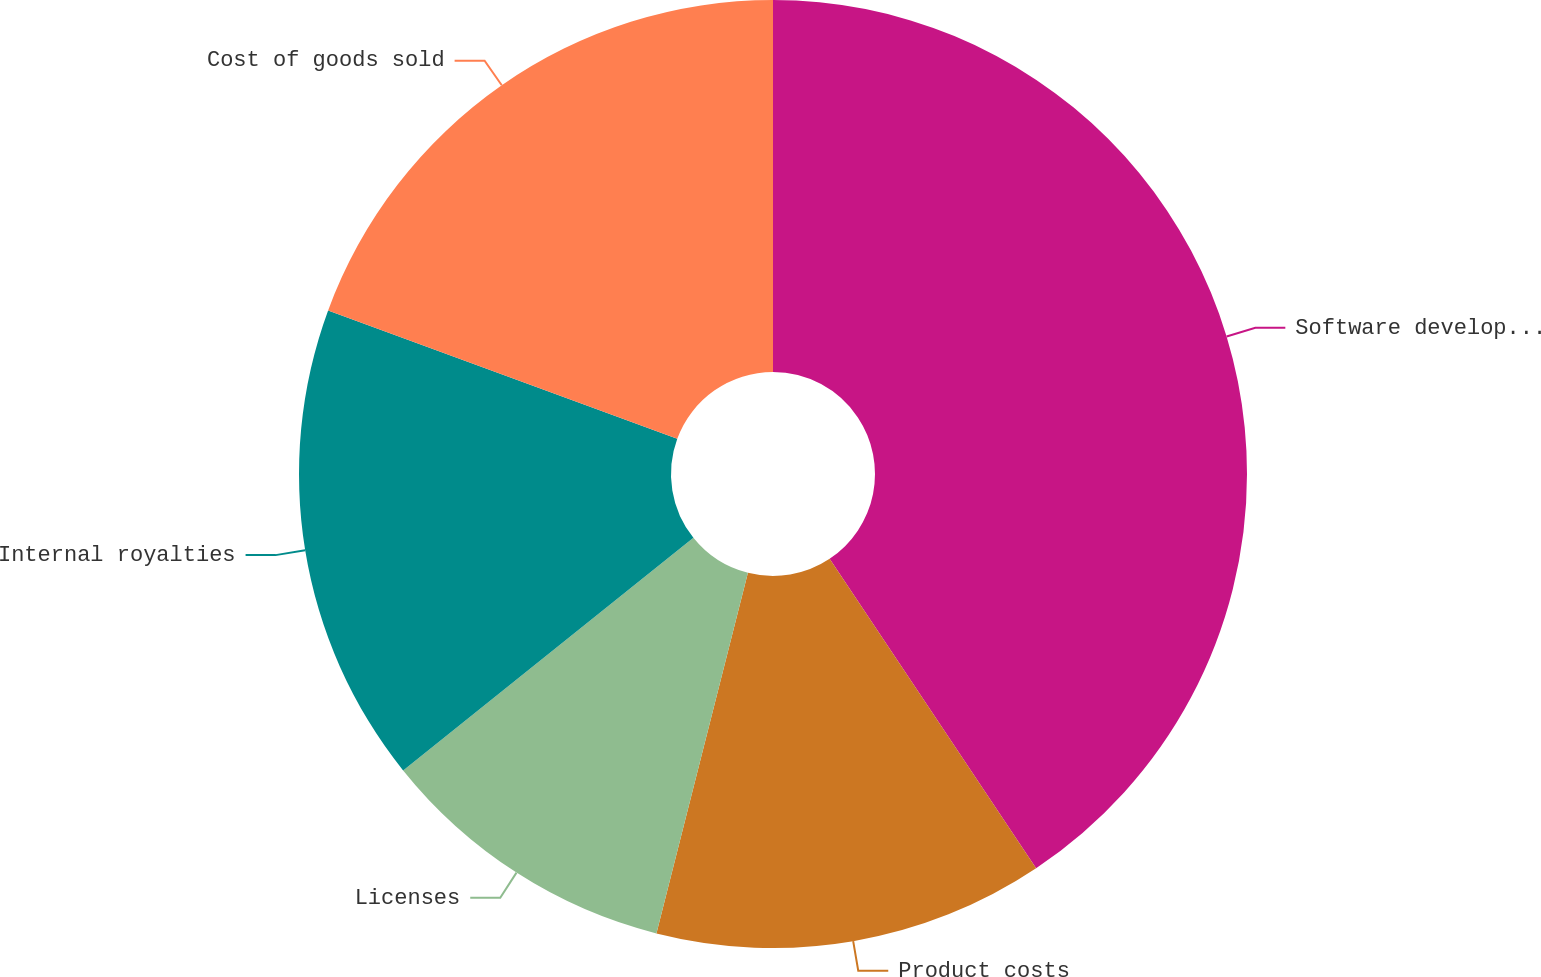Convert chart to OTSL. <chart><loc_0><loc_0><loc_500><loc_500><pie_chart><fcel>Software development costs and<fcel>Product costs<fcel>Licenses<fcel>Internal royalties<fcel>Cost of goods sold<nl><fcel>40.63%<fcel>13.32%<fcel>10.29%<fcel>16.36%<fcel>19.39%<nl></chart> 